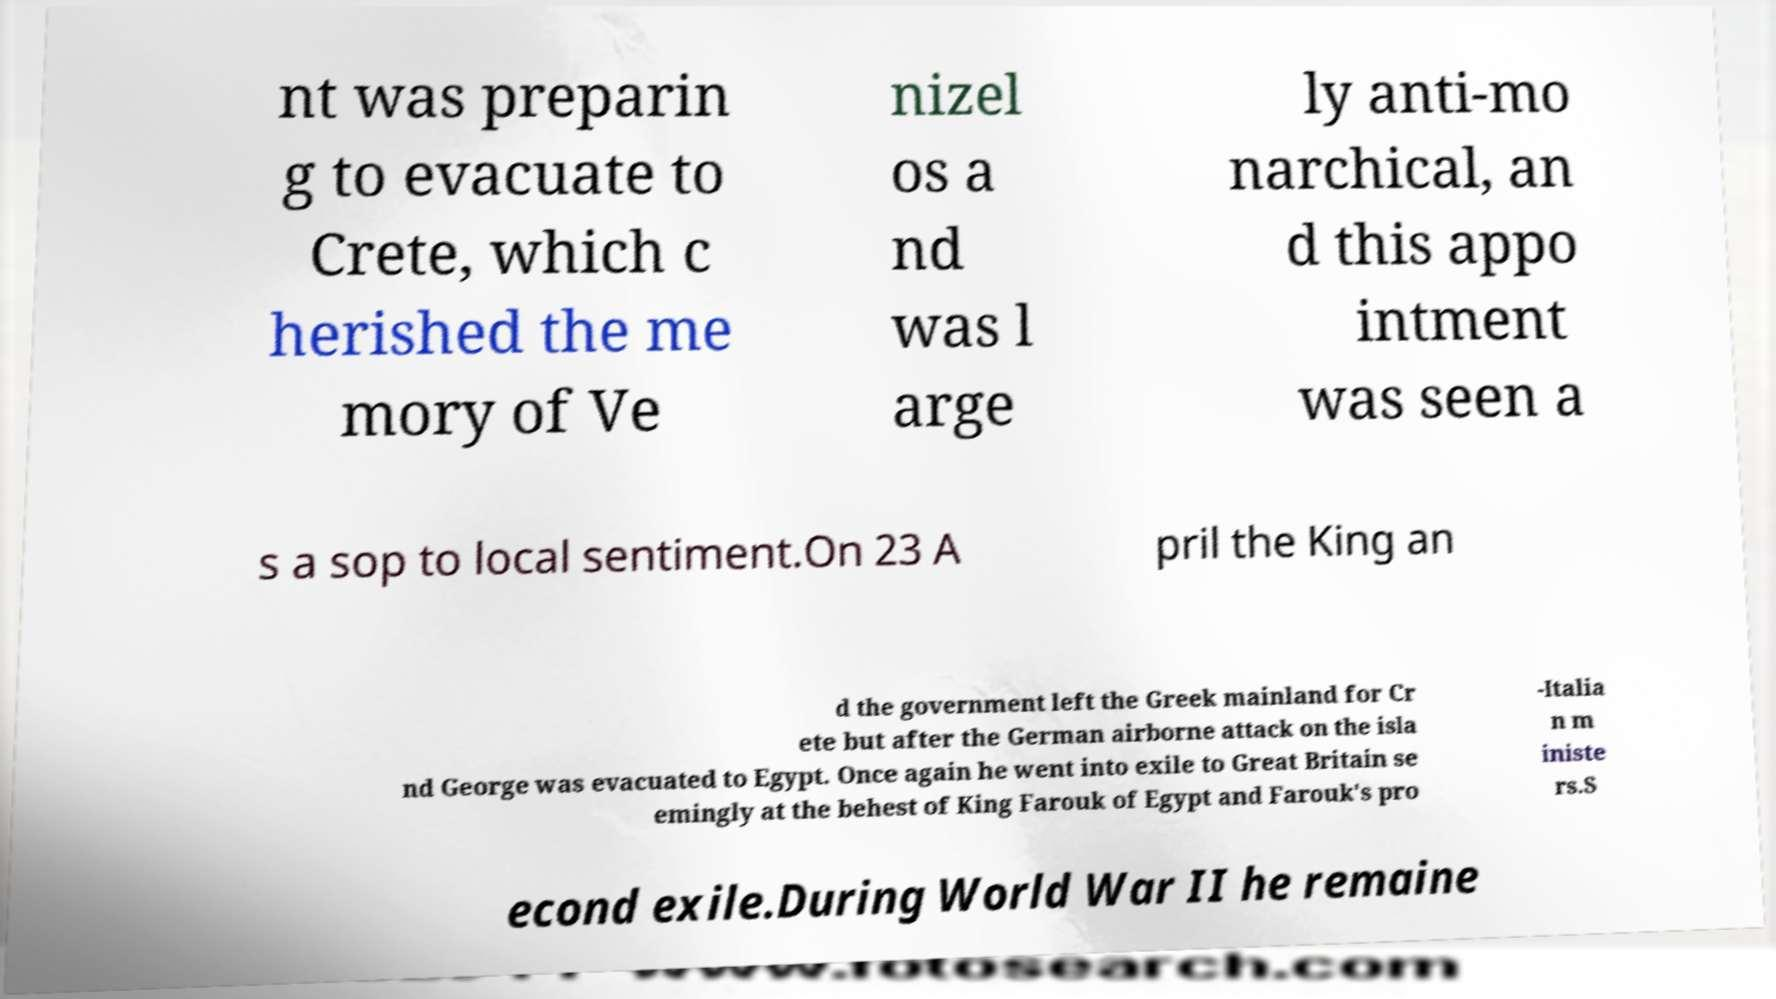Can you accurately transcribe the text from the provided image for me? nt was preparin g to evacuate to Crete, which c herished the me mory of Ve nizel os a nd was l arge ly anti-mo narchical, an d this appo intment was seen a s a sop to local sentiment.On 23 A pril the King an d the government left the Greek mainland for Cr ete but after the German airborne attack on the isla nd George was evacuated to Egypt. Once again he went into exile to Great Britain se emingly at the behest of King Farouk of Egypt and Farouk's pro -Italia n m iniste rs.S econd exile.During World War II he remaine 